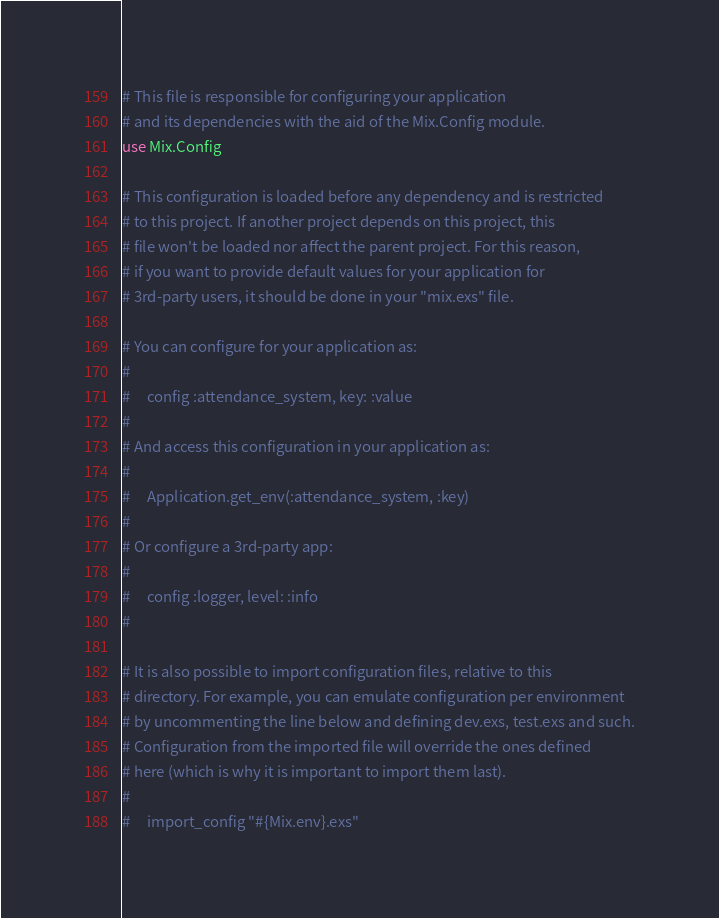Convert code to text. <code><loc_0><loc_0><loc_500><loc_500><_Elixir_># This file is responsible for configuring your application
# and its dependencies with the aid of the Mix.Config module.
use Mix.Config

# This configuration is loaded before any dependency and is restricted
# to this project. If another project depends on this project, this
# file won't be loaded nor affect the parent project. For this reason,
# if you want to provide default values for your application for
# 3rd-party users, it should be done in your "mix.exs" file.

# You can configure for your application as:
#
#     config :attendance_system, key: :value
#
# And access this configuration in your application as:
#
#     Application.get_env(:attendance_system, :key)
#
# Or configure a 3rd-party app:
#
#     config :logger, level: :info
#

# It is also possible to import configuration files, relative to this
# directory. For example, you can emulate configuration per environment
# by uncommenting the line below and defining dev.exs, test.exs and such.
# Configuration from the imported file will override the ones defined
# here (which is why it is important to import them last).
#
#     import_config "#{Mix.env}.exs"
</code> 